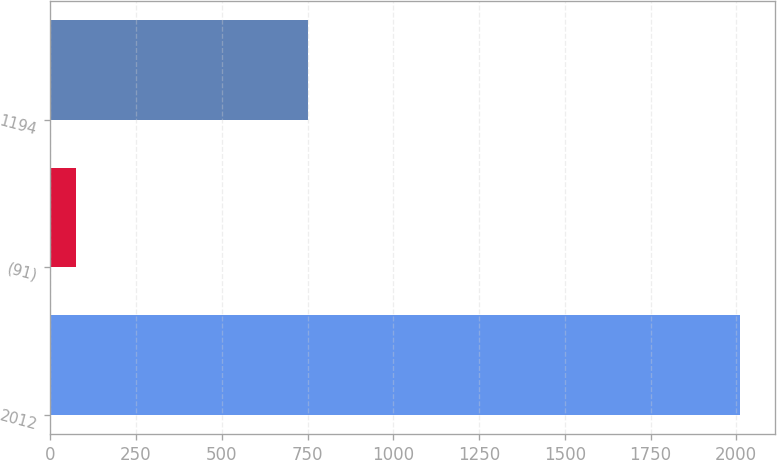<chart> <loc_0><loc_0><loc_500><loc_500><bar_chart><fcel>2012<fcel>(91)<fcel>1194<nl><fcel>2011<fcel>75<fcel>751<nl></chart> 